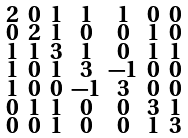Convert formula to latex. <formula><loc_0><loc_0><loc_500><loc_500>\begin{smallmatrix} 2 & 0 & 1 & 1 & 1 & 0 & 0 \\ 0 & 2 & 1 & 0 & 0 & 1 & 0 \\ 1 & 1 & 3 & 1 & 0 & 1 & 1 \\ 1 & 0 & 1 & 3 & - 1 & 0 & 0 \\ 1 & 0 & 0 & - 1 & 3 & 0 & 0 \\ 0 & 1 & 1 & 0 & 0 & 3 & 1 \\ 0 & 0 & 1 & 0 & 0 & 1 & 3 \end{smallmatrix}</formula> 